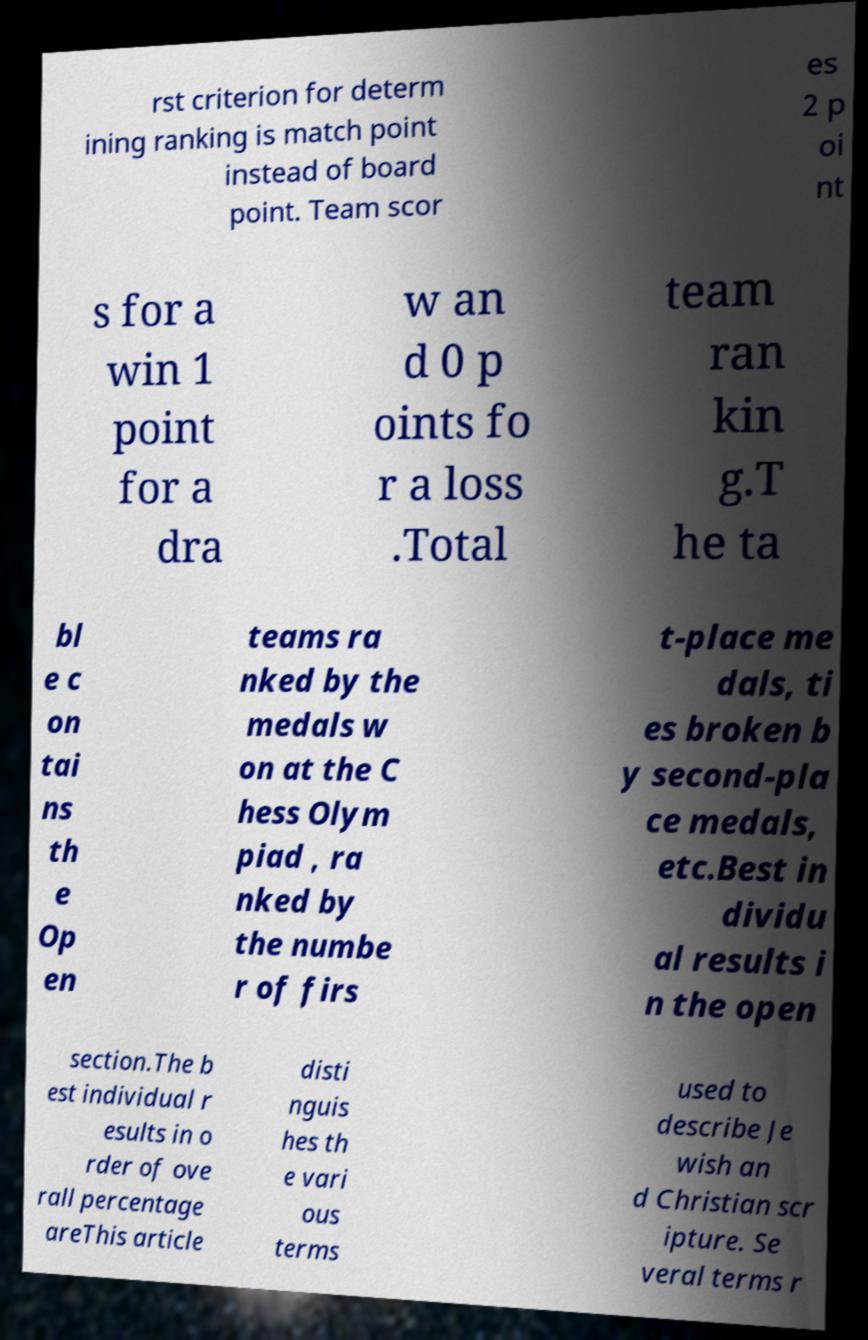What messages or text are displayed in this image? I need them in a readable, typed format. rst criterion for determ ining ranking is match point instead of board point. Team scor es 2 p oi nt s for a win 1 point for a dra w an d 0 p oints fo r a loss .Total team ran kin g.T he ta bl e c on tai ns th e Op en teams ra nked by the medals w on at the C hess Olym piad , ra nked by the numbe r of firs t-place me dals, ti es broken b y second-pla ce medals, etc.Best in dividu al results i n the open section.The b est individual r esults in o rder of ove rall percentage areThis article disti nguis hes th e vari ous terms used to describe Je wish an d Christian scr ipture. Se veral terms r 